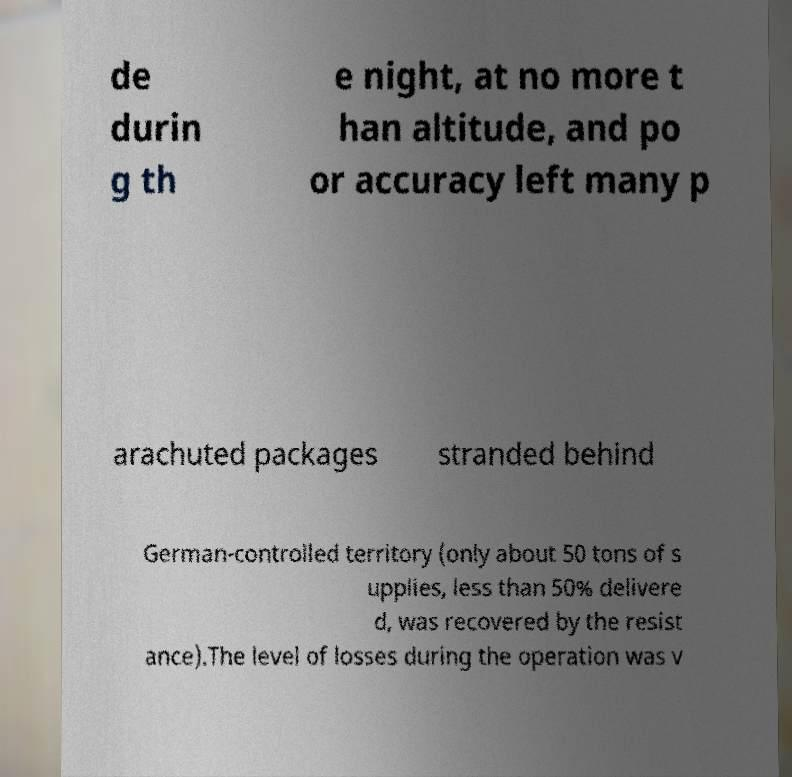For documentation purposes, I need the text within this image transcribed. Could you provide that? de durin g th e night, at no more t han altitude, and po or accuracy left many p arachuted packages stranded behind German-controlled territory (only about 50 tons of s upplies, less than 50% delivere d, was recovered by the resist ance).The level of losses during the operation was v 